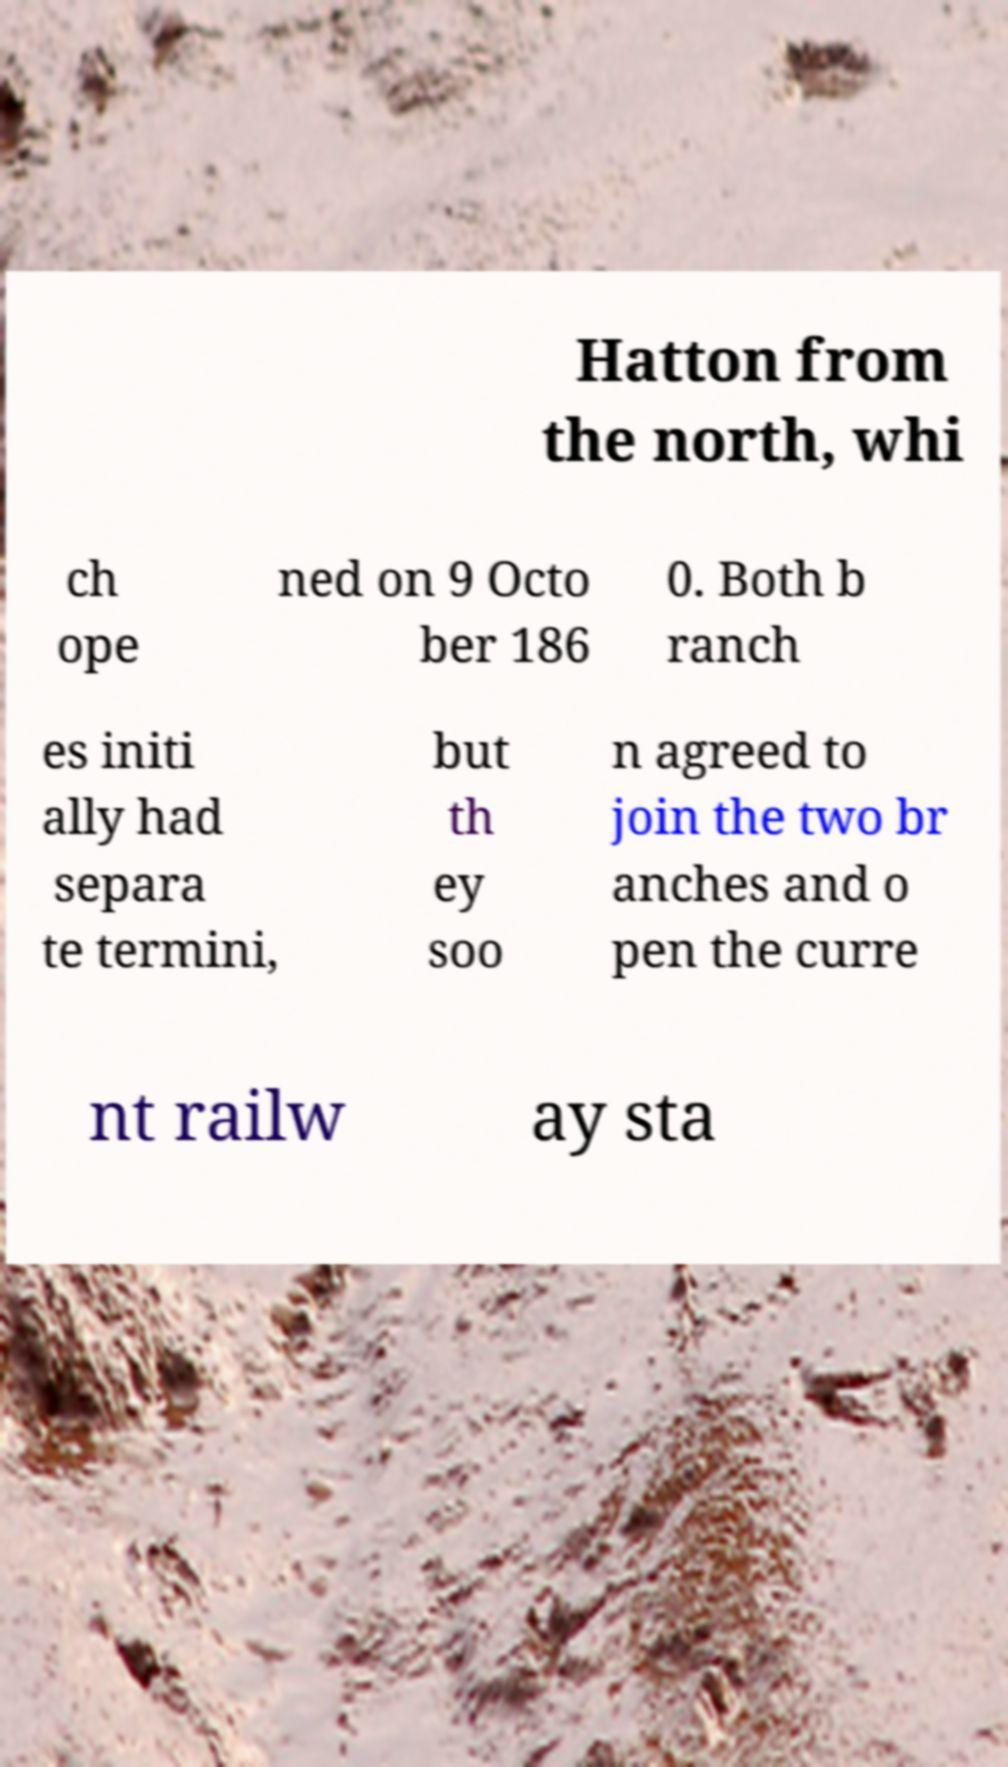Could you assist in decoding the text presented in this image and type it out clearly? Hatton from the north, whi ch ope ned on 9 Octo ber 186 0. Both b ranch es initi ally had separa te termini, but th ey soo n agreed to join the two br anches and o pen the curre nt railw ay sta 